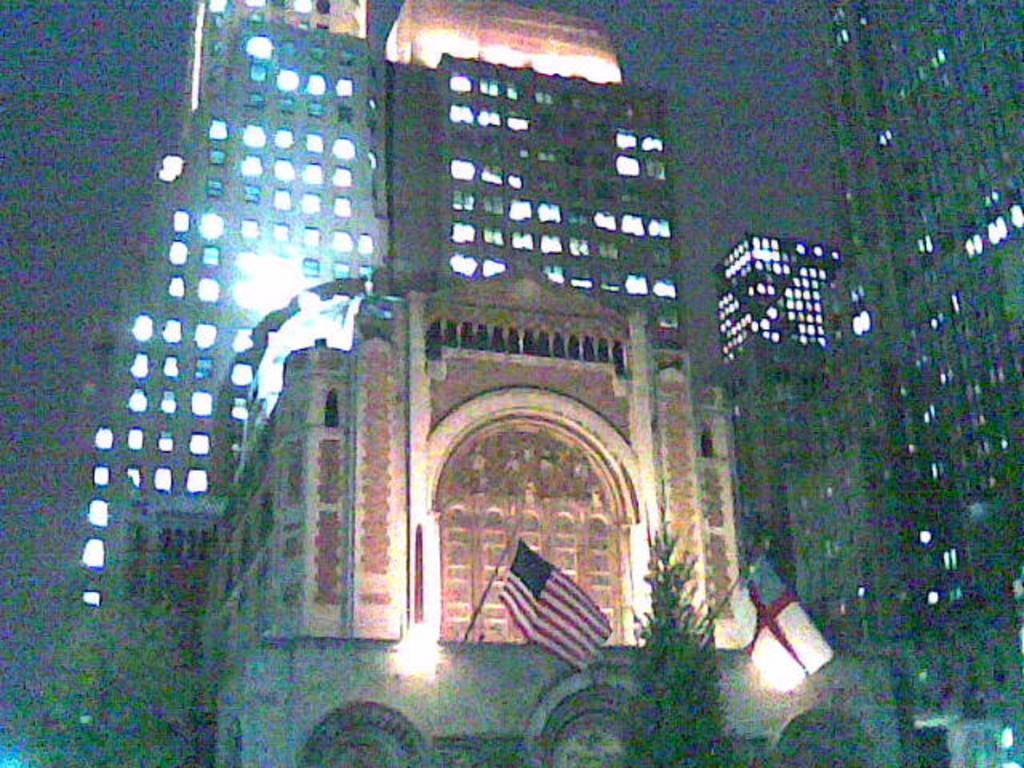How would you summarize this image in a sentence or two? In this image, we can see few buildings with walls and lights. At the bottom, we can see a tree, few flags with poles. 